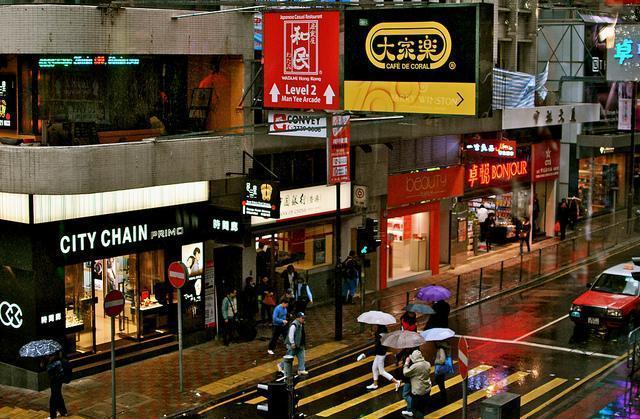How many cars can be seen?
Give a very brief answer. 1. 